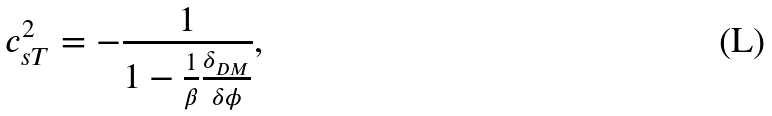Convert formula to latex. <formula><loc_0><loc_0><loc_500><loc_500>c _ { s T } ^ { 2 } = - \frac { 1 } { 1 - \frac { 1 } { \beta } \frac { \delta _ { D M } } { \delta \phi } } ,</formula> 